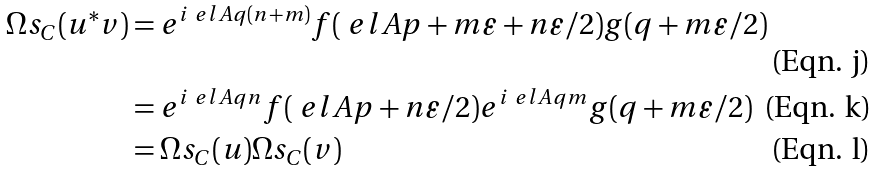Convert formula to latex. <formula><loc_0><loc_0><loc_500><loc_500>\Omega s _ { C } ( u ^ { * } v ) & = e ^ { i \ e l A q ( n + m ) } f ( \ e l A p + m \varepsilon + n \varepsilon / 2 ) g ( q + m \varepsilon / 2 ) \\ & = e ^ { i \ e l A q n } f ( \ e l A p + n \varepsilon / 2 ) e ^ { i \ e l A q m } g ( q + m \varepsilon / 2 ) \\ & = \Omega s _ { C } ( u ) \Omega s _ { C } ( v )</formula> 